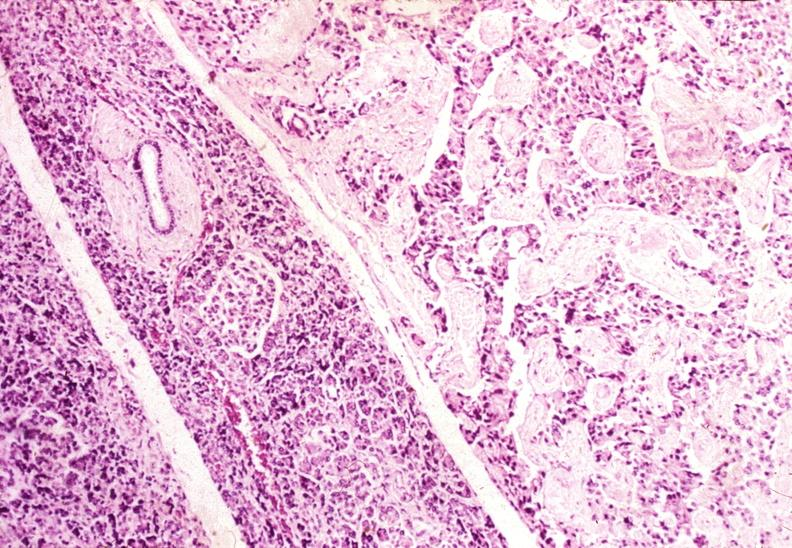s complex craniofacial abnormalities present?
Answer the question using a single word or phrase. No 